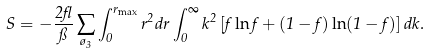Convert formula to latex. <formula><loc_0><loc_0><loc_500><loc_500>S = - \frac { 2 \gamma } { \pi } \sum _ { \tau _ { 3 } } \int _ { 0 } ^ { r _ { \max } } r ^ { 2 } d r \int _ { 0 } ^ { \infty } k ^ { 2 } \left [ f \ln f + ( 1 - f ) \ln ( 1 - f ) \right ] d k .</formula> 